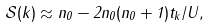Convert formula to latex. <formula><loc_0><loc_0><loc_500><loc_500>\mathcal { S } ( { k } ) \approx n _ { 0 } - 2 n _ { 0 } ( n _ { 0 } + 1 ) t _ { k } / U ,</formula> 